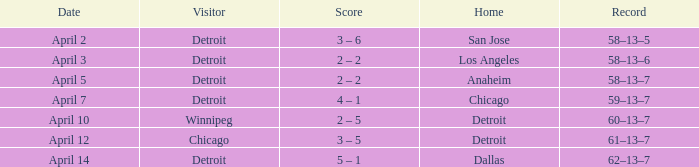Who was the home team in the game having a visitor of Chicago? Detroit. 